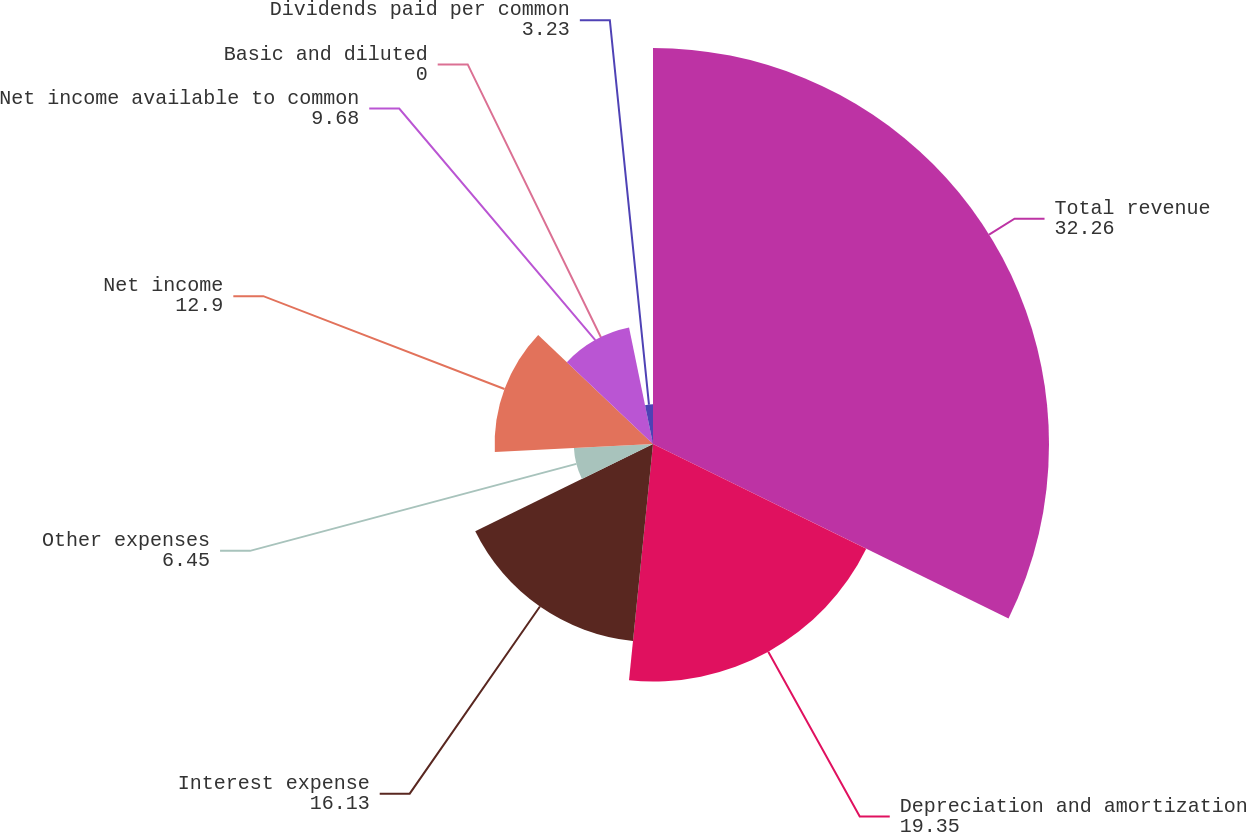Convert chart. <chart><loc_0><loc_0><loc_500><loc_500><pie_chart><fcel>Total revenue<fcel>Depreciation and amortization<fcel>Interest expense<fcel>Other expenses<fcel>Net income<fcel>Net income available to common<fcel>Basic and diluted<fcel>Dividends paid per common<nl><fcel>32.26%<fcel>19.35%<fcel>16.13%<fcel>6.45%<fcel>12.9%<fcel>9.68%<fcel>0.0%<fcel>3.23%<nl></chart> 